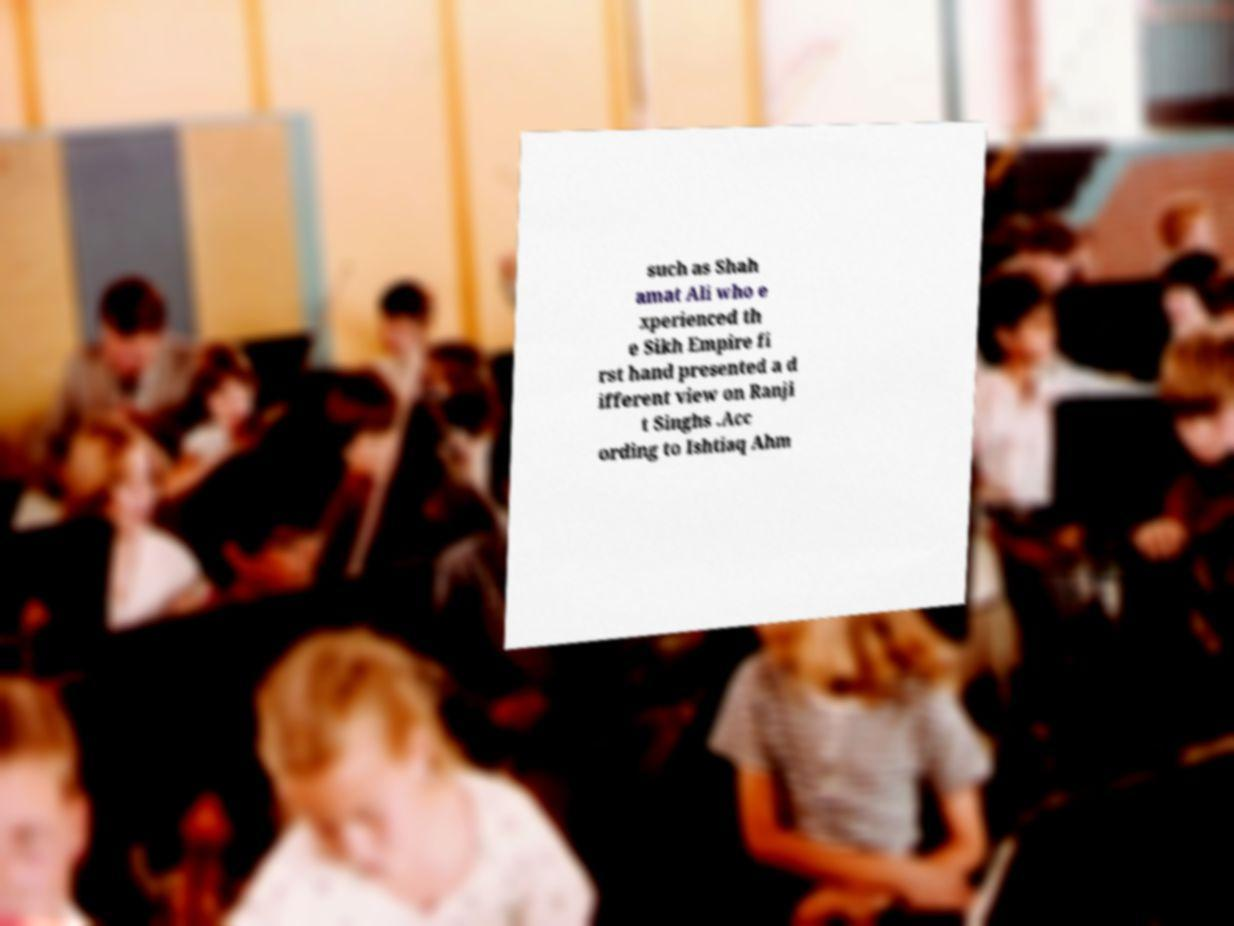Could you assist in decoding the text presented in this image and type it out clearly? such as Shah amat Ali who e xperienced th e Sikh Empire fi rst hand presented a d ifferent view on Ranji t Singhs .Acc ording to Ishtiaq Ahm 